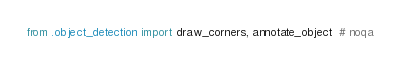Convert code to text. <code><loc_0><loc_0><loc_500><loc_500><_Python_>from .object_detection import draw_corners, annotate_object  # noqa
</code> 